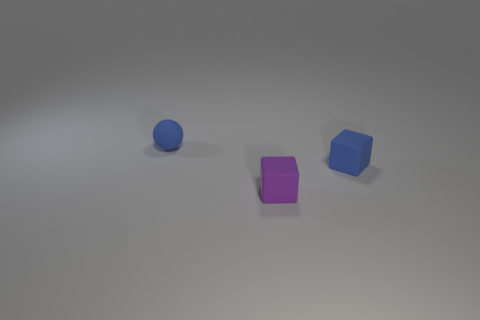Add 1 blue blocks. How many objects exist? 4 Subtract all cubes. How many objects are left? 1 Subtract 0 yellow cubes. How many objects are left? 3 Subtract all purple things. Subtract all small cyan metallic cubes. How many objects are left? 2 Add 1 blue objects. How many blue objects are left? 3 Add 2 big balls. How many big balls exist? 2 